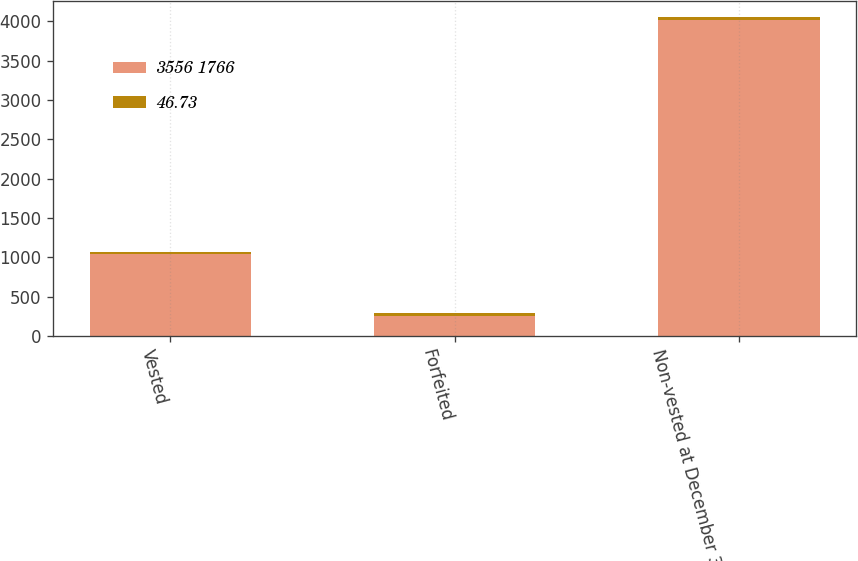<chart> <loc_0><loc_0><loc_500><loc_500><stacked_bar_chart><ecel><fcel>Vested<fcel>Forfeited<fcel>Non-vested at December 31 2015<nl><fcel>3556 1766<fcel>1044<fcel>258<fcel>4020<nl><fcel>46.73<fcel>26.69<fcel>36.33<fcel>40.99<nl></chart> 